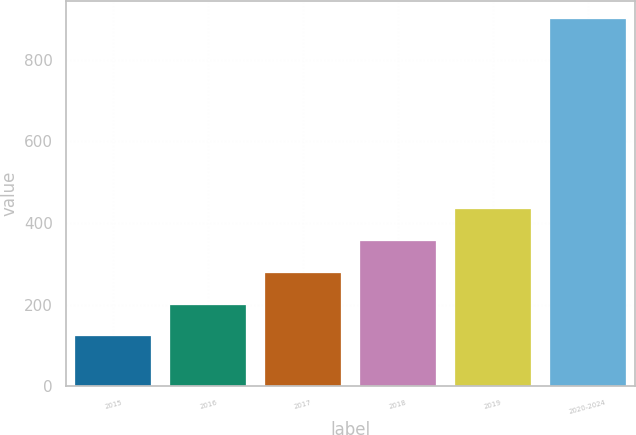Convert chart. <chart><loc_0><loc_0><loc_500><loc_500><bar_chart><fcel>2015<fcel>2016<fcel>2017<fcel>2018<fcel>2019<fcel>2020-2024<nl><fcel>122.5<fcel>200.17<fcel>277.84<fcel>355.51<fcel>433.18<fcel>899.2<nl></chart> 